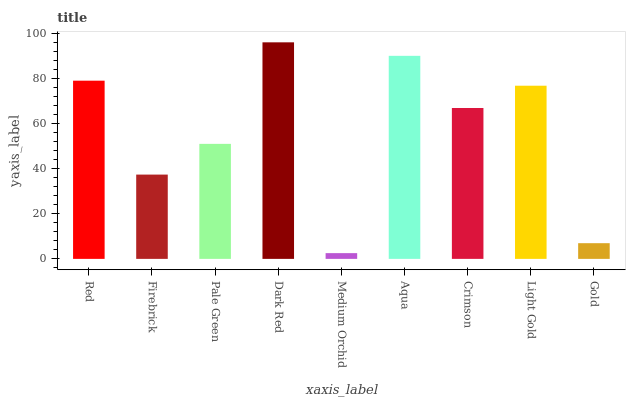Is Medium Orchid the minimum?
Answer yes or no. Yes. Is Dark Red the maximum?
Answer yes or no. Yes. Is Firebrick the minimum?
Answer yes or no. No. Is Firebrick the maximum?
Answer yes or no. No. Is Red greater than Firebrick?
Answer yes or no. Yes. Is Firebrick less than Red?
Answer yes or no. Yes. Is Firebrick greater than Red?
Answer yes or no. No. Is Red less than Firebrick?
Answer yes or no. No. Is Crimson the high median?
Answer yes or no. Yes. Is Crimson the low median?
Answer yes or no. Yes. Is Firebrick the high median?
Answer yes or no. No. Is Firebrick the low median?
Answer yes or no. No. 